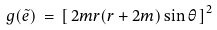Convert formula to latex. <formula><loc_0><loc_0><loc_500><loc_500>g ( \tilde { e } ) \, = \, \left [ \, 2 m r ( r + 2 m ) \sin \theta \, \right ] ^ { 2 }</formula> 